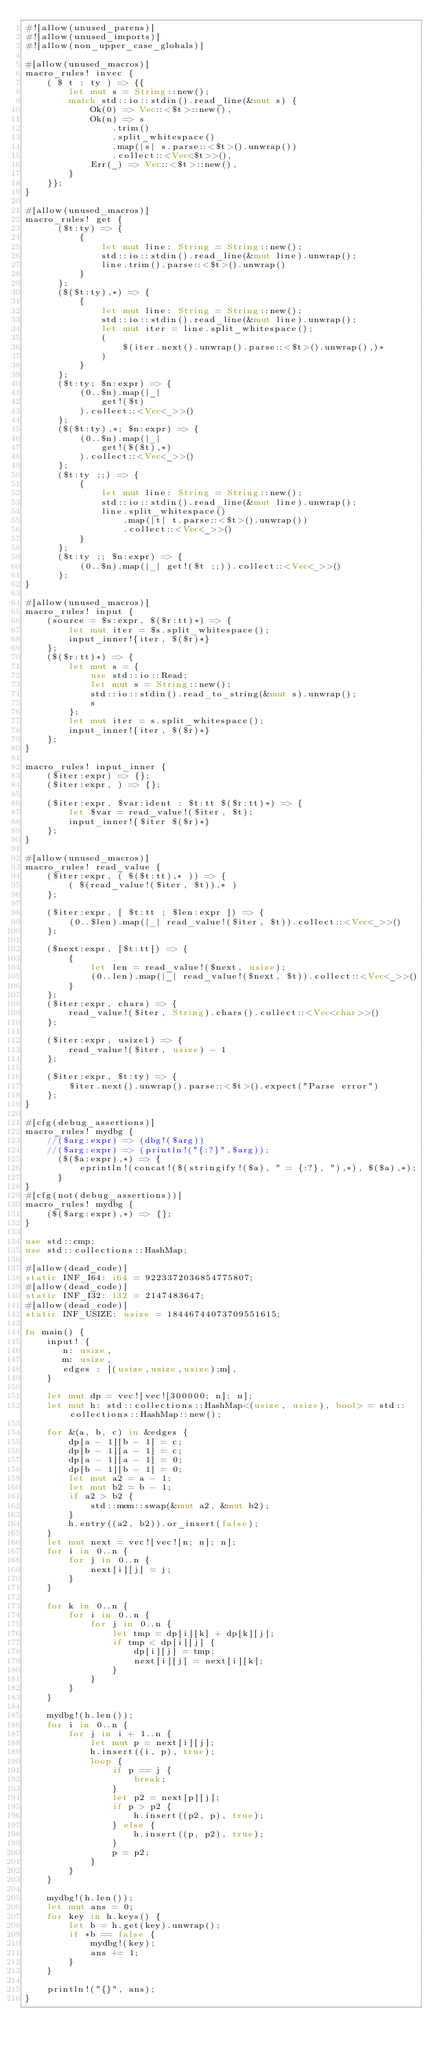Convert code to text. <code><loc_0><loc_0><loc_500><loc_500><_Rust_>#![allow(unused_parens)]
#![allow(unused_imports)]
#![allow(non_upper_case_globals)]

#[allow(unused_macros)]
macro_rules! invec {
    ( $ t : ty ) => {{
        let mut s = String::new();
        match std::io::stdin().read_line(&mut s) {
            Ok(0) => Vec::<$t>::new(),
            Ok(n) => s
                .trim()
                .split_whitespace()
                .map(|s| s.parse::<$t>().unwrap())
                .collect::<Vec<$t>>(),
            Err(_) => Vec::<$t>::new(),
        }
    }};
}

#[allow(unused_macros)]
macro_rules! get {
      ($t:ty) => {
          {
              let mut line: String = String::new();
              std::io::stdin().read_line(&mut line).unwrap();
              line.trim().parse::<$t>().unwrap()
          }
      };
      ($($t:ty),*) => {
          {
              let mut line: String = String::new();
              std::io::stdin().read_line(&mut line).unwrap();
              let mut iter = line.split_whitespace();
              (
                  $(iter.next().unwrap().parse::<$t>().unwrap(),)*
              )
          }
      };
      ($t:ty; $n:expr) => {
          (0..$n).map(|_|
              get!($t)
          ).collect::<Vec<_>>()
      };
      ($($t:ty),*; $n:expr) => {
          (0..$n).map(|_|
              get!($($t),*)
          ).collect::<Vec<_>>()
      };
      ($t:ty ;;) => {
          {
              let mut line: String = String::new();
              std::io::stdin().read_line(&mut line).unwrap();
              line.split_whitespace()
                  .map(|t| t.parse::<$t>().unwrap())
                  .collect::<Vec<_>>()
          }
      };
      ($t:ty ;; $n:expr) => {
          (0..$n).map(|_| get!($t ;;)).collect::<Vec<_>>()
      };
}

#[allow(unused_macros)]
macro_rules! input {
    (source = $s:expr, $($r:tt)*) => {
        let mut iter = $s.split_whitespace();
        input_inner!{iter, $($r)*}
    };
    ($($r:tt)*) => {
        let mut s = {
            use std::io::Read;
            let mut s = String::new();
            std::io::stdin().read_to_string(&mut s).unwrap();
            s
        };
        let mut iter = s.split_whitespace();
        input_inner!{iter, $($r)*}
    };
}

macro_rules! input_inner {
    ($iter:expr) => {};
    ($iter:expr, ) => {};

    ($iter:expr, $var:ident : $t:tt $($r:tt)*) => {
        let $var = read_value!($iter, $t);
        input_inner!{$iter $($r)*}
    };
}

#[allow(unused_macros)]
macro_rules! read_value {
    ($iter:expr, ( $($t:tt),* )) => {
        ( $(read_value!($iter, $t)),* )
    };

    ($iter:expr, [ $t:tt ; $len:expr ]) => {
        (0..$len).map(|_| read_value!($iter, $t)).collect::<Vec<_>>()
    };

    ($next:expr, [$t:tt]) => {
        {
            let len = read_value!($next, usize);
            (0..len).map(|_| read_value!($next, $t)).collect::<Vec<_>>()
        }
    };
    ($iter:expr, chars) => {
        read_value!($iter, String).chars().collect::<Vec<char>>()
    };

    ($iter:expr, usize1) => {
        read_value!($iter, usize) - 1
    };

    ($iter:expr, $t:ty) => {
        $iter.next().unwrap().parse::<$t>().expect("Parse error")
    };
}

#[cfg(debug_assertions)]
macro_rules! mydbg {
    //($arg:expr) => (dbg!($arg))
    //($arg:expr) => (println!("{:?}",$arg));
      ($($a:expr),*) => {
          eprintln!(concat!($(stringify!($a), " = {:?}, "),*), $($a),*);
      }
}
#[cfg(not(debug_assertions))]
macro_rules! mydbg {
    ($($arg:expr),*) => {};
}

use std::cmp;
use std::collections::HashMap;

#[allow(dead_code)]
static INF_I64: i64 = 9223372036854775807;
#[allow(dead_code)]
static INF_I32: i32 = 2147483647;
#[allow(dead_code)]
static INF_USIZE: usize = 18446744073709551615;

fn main() {
    input! {
       n: usize,
       m: usize,
       edges : [(usize,usize,usize);m],
    }

    let mut dp = vec![vec![300000; n]; n];
    let mut h: std::collections::HashMap<(usize, usize), bool> = std::collections::HashMap::new();

    for &(a, b, c) in &edges {
        dp[a - 1][b - 1] = c;
        dp[b - 1][a - 1] = c;
        dp[a - 1][a - 1] = 0;
        dp[b - 1][b - 1] = 0;
        let mut a2 = a - 1;
        let mut b2 = b - 1;
        if a2 > b2 {
            std::mem::swap(&mut a2, &mut b2);
        }
        h.entry((a2, b2)).or_insert(false);
    }
    let mut next = vec![vec![n; n]; n];
    for i in 0..n {
        for j in 0..n {
            next[i][j] = j;
        }
    }

    for k in 0..n {
        for i in 0..n {
            for j in 0..n {
                let tmp = dp[i][k] + dp[k][j];
                if tmp < dp[i][j] {
                    dp[i][j] = tmp;
                    next[i][j] = next[i][k];
                }
            }
        }
    }

    mydbg!(h.len());
    for i in 0..n {
        for j in i + 1..n {
            let mut p = next[i][j];
            h.insert((i, p), true);
            loop {
                if p == j {
                    break;
                }
                let p2 = next[p][j];
                if p > p2 {
                    h.insert((p2, p), true);
                } else {
                    h.insert((p, p2), true);
                }
                p = p2;
            }
        }
    }

    mydbg!(h.len());
    let mut ans = 0;
    for key in h.keys() {
        let b = h.get(key).unwrap();
        if *b == false {
            mydbg!(key);
            ans += 1;
        }
    }

    println!("{}", ans);
}
</code> 